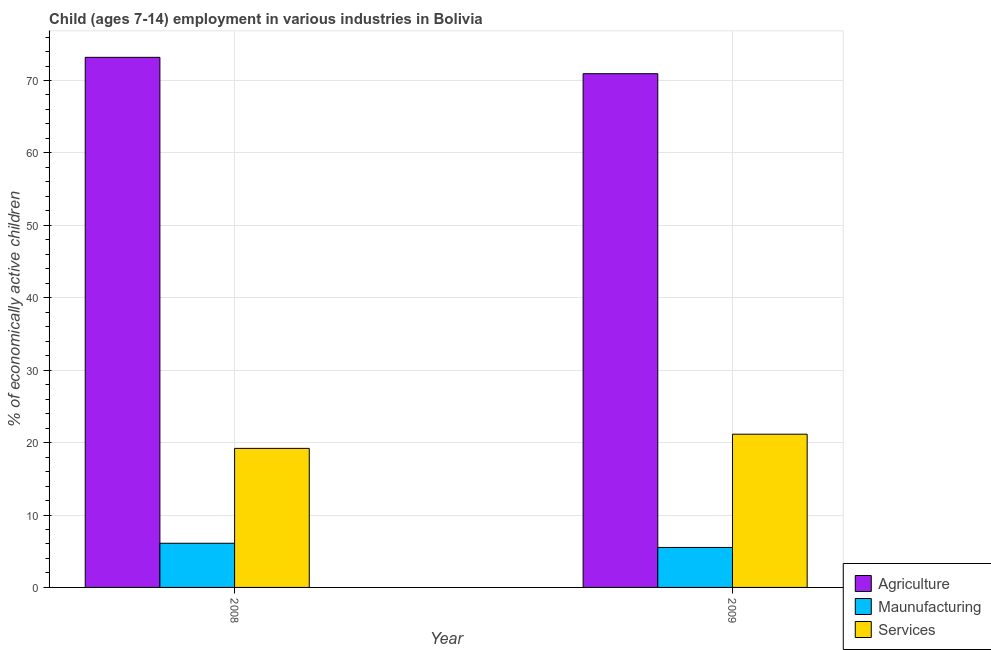How many groups of bars are there?
Offer a very short reply. 2. How many bars are there on the 1st tick from the left?
Keep it short and to the point. 3. In how many cases, is the number of bars for a given year not equal to the number of legend labels?
Your response must be concise. 0. What is the percentage of economically active children in services in 2009?
Offer a very short reply. 21.16. Across all years, what is the maximum percentage of economically active children in manufacturing?
Your answer should be very brief. 6.1. What is the total percentage of economically active children in manufacturing in the graph?
Keep it short and to the point. 11.62. What is the difference between the percentage of economically active children in services in 2008 and that in 2009?
Provide a succinct answer. -1.96. What is the difference between the percentage of economically active children in services in 2008 and the percentage of economically active children in manufacturing in 2009?
Your response must be concise. -1.96. What is the average percentage of economically active children in services per year?
Your answer should be very brief. 20.18. In the year 2009, what is the difference between the percentage of economically active children in manufacturing and percentage of economically active children in agriculture?
Give a very brief answer. 0. What is the ratio of the percentage of economically active children in agriculture in 2008 to that in 2009?
Make the answer very short. 1.03. Is the percentage of economically active children in agriculture in 2008 less than that in 2009?
Make the answer very short. No. In how many years, is the percentage of economically active children in services greater than the average percentage of economically active children in services taken over all years?
Offer a very short reply. 1. What does the 2nd bar from the left in 2009 represents?
Offer a terse response. Maunufacturing. What does the 1st bar from the right in 2009 represents?
Keep it short and to the point. Services. Is it the case that in every year, the sum of the percentage of economically active children in agriculture and percentage of economically active children in manufacturing is greater than the percentage of economically active children in services?
Keep it short and to the point. Yes. Are all the bars in the graph horizontal?
Your response must be concise. No. Does the graph contain grids?
Keep it short and to the point. Yes. How many legend labels are there?
Your answer should be very brief. 3. What is the title of the graph?
Keep it short and to the point. Child (ages 7-14) employment in various industries in Bolivia. Does "Renewable sources" appear as one of the legend labels in the graph?
Give a very brief answer. No. What is the label or title of the X-axis?
Provide a succinct answer. Year. What is the label or title of the Y-axis?
Provide a succinct answer. % of economically active children. What is the % of economically active children of Agriculture in 2008?
Make the answer very short. 73.2. What is the % of economically active children in Services in 2008?
Provide a short and direct response. 19.2. What is the % of economically active children in Agriculture in 2009?
Your answer should be very brief. 70.94. What is the % of economically active children of Maunufacturing in 2009?
Keep it short and to the point. 5.52. What is the % of economically active children of Services in 2009?
Ensure brevity in your answer.  21.16. Across all years, what is the maximum % of economically active children of Agriculture?
Offer a very short reply. 73.2. Across all years, what is the maximum % of economically active children of Services?
Provide a succinct answer. 21.16. Across all years, what is the minimum % of economically active children of Agriculture?
Offer a very short reply. 70.94. Across all years, what is the minimum % of economically active children in Maunufacturing?
Your answer should be compact. 5.52. What is the total % of economically active children of Agriculture in the graph?
Your answer should be compact. 144.14. What is the total % of economically active children of Maunufacturing in the graph?
Give a very brief answer. 11.62. What is the total % of economically active children in Services in the graph?
Make the answer very short. 40.36. What is the difference between the % of economically active children of Agriculture in 2008 and that in 2009?
Offer a very short reply. 2.26. What is the difference between the % of economically active children of Maunufacturing in 2008 and that in 2009?
Your answer should be very brief. 0.58. What is the difference between the % of economically active children in Services in 2008 and that in 2009?
Your response must be concise. -1.96. What is the difference between the % of economically active children of Agriculture in 2008 and the % of economically active children of Maunufacturing in 2009?
Provide a succinct answer. 67.68. What is the difference between the % of economically active children in Agriculture in 2008 and the % of economically active children in Services in 2009?
Keep it short and to the point. 52.04. What is the difference between the % of economically active children in Maunufacturing in 2008 and the % of economically active children in Services in 2009?
Give a very brief answer. -15.06. What is the average % of economically active children of Agriculture per year?
Offer a very short reply. 72.07. What is the average % of economically active children of Maunufacturing per year?
Keep it short and to the point. 5.81. What is the average % of economically active children in Services per year?
Provide a short and direct response. 20.18. In the year 2008, what is the difference between the % of economically active children in Agriculture and % of economically active children in Maunufacturing?
Give a very brief answer. 67.1. In the year 2009, what is the difference between the % of economically active children in Agriculture and % of economically active children in Maunufacturing?
Make the answer very short. 65.42. In the year 2009, what is the difference between the % of economically active children of Agriculture and % of economically active children of Services?
Your response must be concise. 49.78. In the year 2009, what is the difference between the % of economically active children in Maunufacturing and % of economically active children in Services?
Provide a short and direct response. -15.64. What is the ratio of the % of economically active children in Agriculture in 2008 to that in 2009?
Keep it short and to the point. 1.03. What is the ratio of the % of economically active children of Maunufacturing in 2008 to that in 2009?
Keep it short and to the point. 1.11. What is the ratio of the % of economically active children in Services in 2008 to that in 2009?
Your answer should be compact. 0.91. What is the difference between the highest and the second highest % of economically active children of Agriculture?
Provide a succinct answer. 2.26. What is the difference between the highest and the second highest % of economically active children in Maunufacturing?
Offer a very short reply. 0.58. What is the difference between the highest and the second highest % of economically active children of Services?
Provide a short and direct response. 1.96. What is the difference between the highest and the lowest % of economically active children in Agriculture?
Ensure brevity in your answer.  2.26. What is the difference between the highest and the lowest % of economically active children of Maunufacturing?
Provide a succinct answer. 0.58. What is the difference between the highest and the lowest % of economically active children in Services?
Provide a short and direct response. 1.96. 